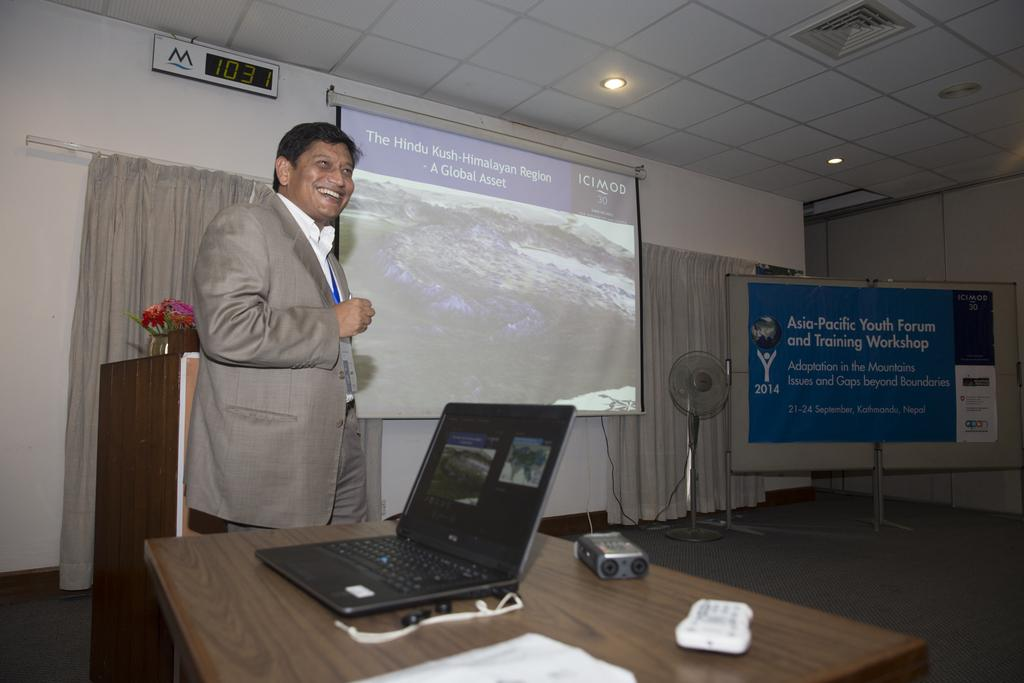What is the color of the wall in the image? The wall in the image is white. What type of window treatment is present in the image? There is a curtain in the image. What device is visible in the image? There is a screen in the image. Who is present in the image? A man is standing in the image. What is hanging on the wall in the image? There is a banner in the image. What is used for cooling in the image? There is a fan in the image. What electronic device is on the table in the image? There is a laptop on the table in the image. What is used for controlling devices in the image? There is a remote on the table in the image. What is made of paper on the table in the image? There is a paper on the table in the image. How many beasts can be seen in the image? There are no beasts present in the image. What number is written on the banner in the image? The banner in the image does not have a number written on it. Is there a monkey sitting on the table in the image? There is no monkey present in the image. 